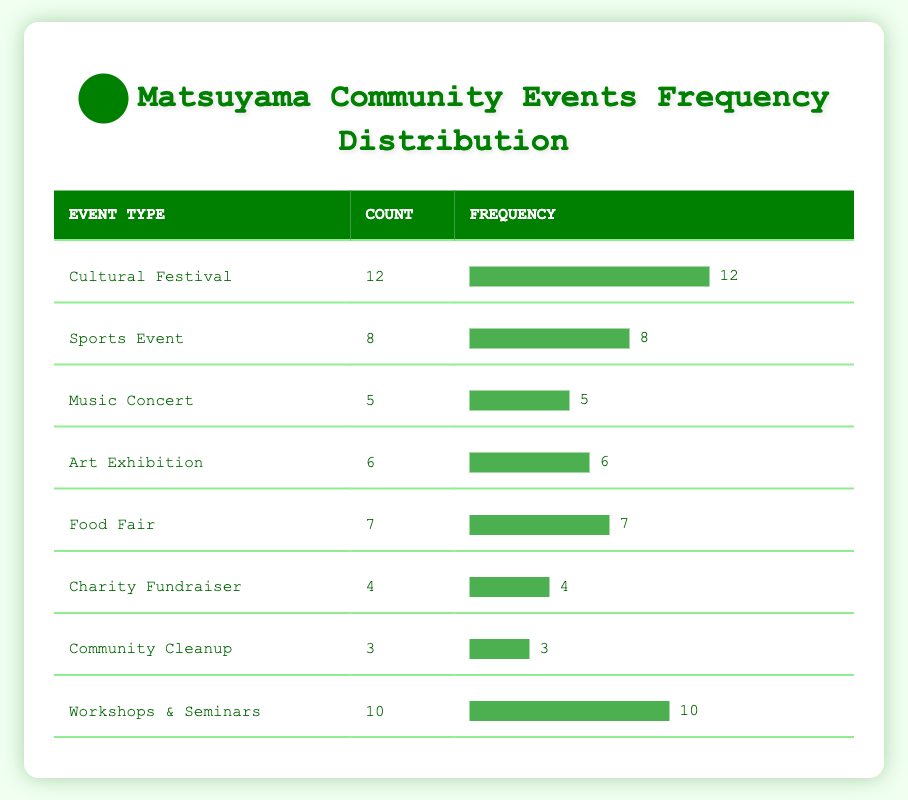What type of event had the highest count in Matsuyama? The table indicates that the event type with the highest count is the "Cultural Festival," which has a count of 12.
Answer: Cultural Festival How many events were categorized as "Food Fair" in Matsuyama? From the table, the "Food Fair" event has a count of 7.
Answer: 7 What is the total count of community events listed in the table? To find the total, add the counts: 12 + 8 + 5 + 6 + 7 + 4 + 3 + 10 = 55. Therefore, the total count of community events is 55.
Answer: 55 What is the average count of events held per event type in Matsuyama? There are 8 event types in total. The sum of all events is 55, so the average is calculated by dividing total by the number of event types: 55 / 8 = 6.875.
Answer: 6.875 Are there more "Workshops & Seminars" held than "Charity Fundraiser" events in Matsuyama? The table shows "Workshops & Seminars" with a count of 10 and "Charity Fundraiser" with a count of 4. Thus, there are more Workshops & Seminars than Charity Fundraisers.
Answer: Yes How many more "Sports Events" are there than "Community Cleanups"? The count for "Sports Events" is 8, and for "Community Cleanups," it is 3. The difference is: 8 - 3 = 5 more Sports Events than Community Cleanups.
Answer: 5 What combined total of events do "Art Exhibition" and "Music Concert" have? The counts for "Art Exhibition" is 6 and for "Music Concert" is 5. Adding these, 6 + 5 = 11. Thus, the combined total for both events is 11.
Answer: 11 Is the count of "Charity Fundraiser" events greater than the count of "Music Concert" events in Matsuyama? The count for "Charity Fundraiser" is 4 and for "Music Concert" is 5. Since 4 is not greater than 5, it is false that Charity Fundraiser events exceed Music Concerts.
Answer: No 